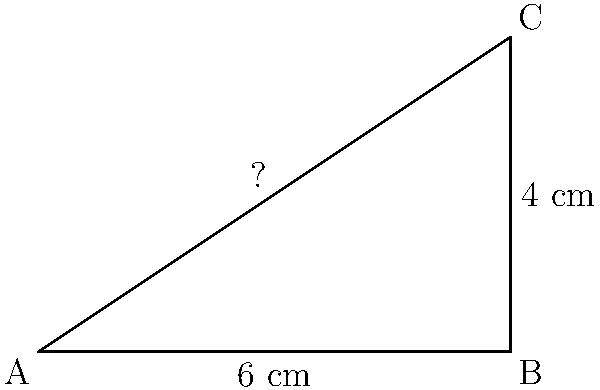Your child is making a cosplay prop sword for an anime convention. The blade of the sword forms a right triangle with a base of 6 cm and a height of 4 cm. What is the length of the blade to the nearest tenth of a centimeter? Let's approach this step-by-step:

1) We can use the Pythagorean theorem to find the length of the blade. The blade forms the hypotenuse of the right triangle.

2) Let's call the length of the blade $c$. We know that:
   $a = 6$ cm (base)
   $b = 4$ cm (height)

3) The Pythagorean theorem states that in a right triangle: $a^2 + b^2 = c^2$

4) Let's substitute our known values:
   $6^2 + 4^2 = c^2$

5) Simplify:
   $36 + 16 = c^2$
   $52 = c^2$

6) Take the square root of both sides:
   $\sqrt{52} = c$

7) Calculate:
   $c \approx 7.211102551$ cm

8) Rounding to the nearest tenth:
   $c \approx 7.2$ cm

Therefore, the length of the blade is approximately 7.2 cm.
Answer: 7.2 cm 